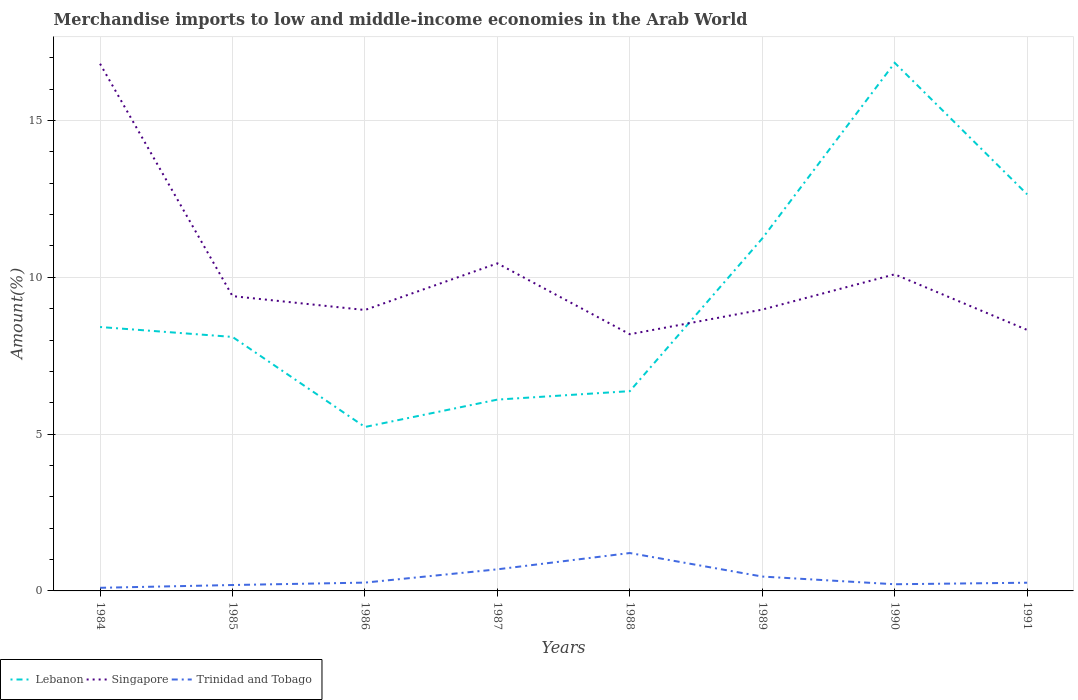Is the number of lines equal to the number of legend labels?
Give a very brief answer. Yes. Across all years, what is the maximum percentage of amount earned from merchandise imports in Lebanon?
Keep it short and to the point. 5.23. What is the total percentage of amount earned from merchandise imports in Trinidad and Tobago in the graph?
Offer a terse response. 0.43. What is the difference between the highest and the second highest percentage of amount earned from merchandise imports in Trinidad and Tobago?
Offer a very short reply. 1.11. Is the percentage of amount earned from merchandise imports in Singapore strictly greater than the percentage of amount earned from merchandise imports in Lebanon over the years?
Offer a very short reply. No. How many lines are there?
Give a very brief answer. 3. How many years are there in the graph?
Provide a short and direct response. 8. Are the values on the major ticks of Y-axis written in scientific E-notation?
Your response must be concise. No. Does the graph contain any zero values?
Ensure brevity in your answer.  No. How many legend labels are there?
Make the answer very short. 3. What is the title of the graph?
Offer a terse response. Merchandise imports to low and middle-income economies in the Arab World. Does "Latin America(developing only)" appear as one of the legend labels in the graph?
Keep it short and to the point. No. What is the label or title of the X-axis?
Provide a succinct answer. Years. What is the label or title of the Y-axis?
Offer a terse response. Amount(%). What is the Amount(%) in Lebanon in 1984?
Give a very brief answer. 8.42. What is the Amount(%) of Singapore in 1984?
Make the answer very short. 16.81. What is the Amount(%) of Trinidad and Tobago in 1984?
Keep it short and to the point. 0.1. What is the Amount(%) of Lebanon in 1985?
Your answer should be compact. 8.1. What is the Amount(%) of Singapore in 1985?
Offer a terse response. 9.4. What is the Amount(%) of Trinidad and Tobago in 1985?
Offer a terse response. 0.19. What is the Amount(%) of Lebanon in 1986?
Ensure brevity in your answer.  5.23. What is the Amount(%) of Singapore in 1986?
Your answer should be compact. 8.96. What is the Amount(%) of Trinidad and Tobago in 1986?
Your answer should be very brief. 0.26. What is the Amount(%) of Lebanon in 1987?
Provide a short and direct response. 6.1. What is the Amount(%) of Singapore in 1987?
Give a very brief answer. 10.45. What is the Amount(%) of Trinidad and Tobago in 1987?
Offer a terse response. 0.69. What is the Amount(%) of Lebanon in 1988?
Offer a very short reply. 6.37. What is the Amount(%) in Singapore in 1988?
Your answer should be very brief. 8.19. What is the Amount(%) in Trinidad and Tobago in 1988?
Your answer should be compact. 1.21. What is the Amount(%) in Lebanon in 1989?
Your answer should be very brief. 11.24. What is the Amount(%) in Singapore in 1989?
Provide a succinct answer. 8.97. What is the Amount(%) of Trinidad and Tobago in 1989?
Provide a succinct answer. 0.46. What is the Amount(%) of Lebanon in 1990?
Provide a short and direct response. 16.84. What is the Amount(%) in Singapore in 1990?
Your response must be concise. 10.1. What is the Amount(%) of Trinidad and Tobago in 1990?
Your answer should be compact. 0.21. What is the Amount(%) in Lebanon in 1991?
Your response must be concise. 12.65. What is the Amount(%) of Singapore in 1991?
Your answer should be compact. 8.32. What is the Amount(%) in Trinidad and Tobago in 1991?
Give a very brief answer. 0.26. Across all years, what is the maximum Amount(%) of Lebanon?
Your response must be concise. 16.84. Across all years, what is the maximum Amount(%) of Singapore?
Provide a short and direct response. 16.81. Across all years, what is the maximum Amount(%) in Trinidad and Tobago?
Your answer should be very brief. 1.21. Across all years, what is the minimum Amount(%) in Lebanon?
Keep it short and to the point. 5.23. Across all years, what is the minimum Amount(%) of Singapore?
Keep it short and to the point. 8.19. Across all years, what is the minimum Amount(%) in Trinidad and Tobago?
Provide a succinct answer. 0.1. What is the total Amount(%) in Lebanon in the graph?
Offer a very short reply. 74.94. What is the total Amount(%) in Singapore in the graph?
Ensure brevity in your answer.  81.19. What is the total Amount(%) in Trinidad and Tobago in the graph?
Your answer should be compact. 3.38. What is the difference between the Amount(%) in Lebanon in 1984 and that in 1985?
Make the answer very short. 0.32. What is the difference between the Amount(%) of Singapore in 1984 and that in 1985?
Your answer should be compact. 7.41. What is the difference between the Amount(%) in Trinidad and Tobago in 1984 and that in 1985?
Offer a terse response. -0.09. What is the difference between the Amount(%) in Lebanon in 1984 and that in 1986?
Offer a terse response. 3.19. What is the difference between the Amount(%) of Singapore in 1984 and that in 1986?
Provide a succinct answer. 7.85. What is the difference between the Amount(%) of Trinidad and Tobago in 1984 and that in 1986?
Your answer should be compact. -0.17. What is the difference between the Amount(%) of Lebanon in 1984 and that in 1987?
Your response must be concise. 2.31. What is the difference between the Amount(%) in Singapore in 1984 and that in 1987?
Provide a succinct answer. 6.36. What is the difference between the Amount(%) in Trinidad and Tobago in 1984 and that in 1987?
Make the answer very short. -0.59. What is the difference between the Amount(%) of Lebanon in 1984 and that in 1988?
Ensure brevity in your answer.  2.04. What is the difference between the Amount(%) of Singapore in 1984 and that in 1988?
Your answer should be compact. 8.62. What is the difference between the Amount(%) of Trinidad and Tobago in 1984 and that in 1988?
Make the answer very short. -1.11. What is the difference between the Amount(%) of Lebanon in 1984 and that in 1989?
Provide a succinct answer. -2.82. What is the difference between the Amount(%) of Singapore in 1984 and that in 1989?
Provide a succinct answer. 7.84. What is the difference between the Amount(%) of Trinidad and Tobago in 1984 and that in 1989?
Ensure brevity in your answer.  -0.36. What is the difference between the Amount(%) of Lebanon in 1984 and that in 1990?
Offer a terse response. -8.42. What is the difference between the Amount(%) in Singapore in 1984 and that in 1990?
Provide a short and direct response. 6.71. What is the difference between the Amount(%) in Trinidad and Tobago in 1984 and that in 1990?
Provide a short and direct response. -0.11. What is the difference between the Amount(%) in Lebanon in 1984 and that in 1991?
Keep it short and to the point. -4.23. What is the difference between the Amount(%) in Singapore in 1984 and that in 1991?
Offer a very short reply. 8.49. What is the difference between the Amount(%) in Trinidad and Tobago in 1984 and that in 1991?
Keep it short and to the point. -0.16. What is the difference between the Amount(%) of Lebanon in 1985 and that in 1986?
Provide a succinct answer. 2.87. What is the difference between the Amount(%) in Singapore in 1985 and that in 1986?
Your answer should be compact. 0.44. What is the difference between the Amount(%) in Trinidad and Tobago in 1985 and that in 1986?
Provide a succinct answer. -0.08. What is the difference between the Amount(%) in Lebanon in 1985 and that in 1987?
Your response must be concise. 2. What is the difference between the Amount(%) in Singapore in 1985 and that in 1987?
Offer a very short reply. -1.05. What is the difference between the Amount(%) of Trinidad and Tobago in 1985 and that in 1987?
Keep it short and to the point. -0.5. What is the difference between the Amount(%) in Lebanon in 1985 and that in 1988?
Your response must be concise. 1.73. What is the difference between the Amount(%) in Singapore in 1985 and that in 1988?
Your answer should be compact. 1.21. What is the difference between the Amount(%) of Trinidad and Tobago in 1985 and that in 1988?
Offer a very short reply. -1.02. What is the difference between the Amount(%) of Lebanon in 1985 and that in 1989?
Give a very brief answer. -3.14. What is the difference between the Amount(%) of Singapore in 1985 and that in 1989?
Offer a terse response. 0.43. What is the difference between the Amount(%) in Trinidad and Tobago in 1985 and that in 1989?
Your answer should be very brief. -0.27. What is the difference between the Amount(%) in Lebanon in 1985 and that in 1990?
Your response must be concise. -8.74. What is the difference between the Amount(%) of Singapore in 1985 and that in 1990?
Your response must be concise. -0.7. What is the difference between the Amount(%) of Trinidad and Tobago in 1985 and that in 1990?
Offer a very short reply. -0.02. What is the difference between the Amount(%) in Lebanon in 1985 and that in 1991?
Your response must be concise. -4.55. What is the difference between the Amount(%) of Singapore in 1985 and that in 1991?
Your response must be concise. 1.08. What is the difference between the Amount(%) of Trinidad and Tobago in 1985 and that in 1991?
Offer a terse response. -0.07. What is the difference between the Amount(%) in Lebanon in 1986 and that in 1987?
Your response must be concise. -0.87. What is the difference between the Amount(%) of Singapore in 1986 and that in 1987?
Provide a succinct answer. -1.49. What is the difference between the Amount(%) of Trinidad and Tobago in 1986 and that in 1987?
Give a very brief answer. -0.42. What is the difference between the Amount(%) in Lebanon in 1986 and that in 1988?
Offer a terse response. -1.14. What is the difference between the Amount(%) of Singapore in 1986 and that in 1988?
Provide a short and direct response. 0.77. What is the difference between the Amount(%) of Trinidad and Tobago in 1986 and that in 1988?
Your answer should be very brief. -0.94. What is the difference between the Amount(%) of Lebanon in 1986 and that in 1989?
Make the answer very short. -6.01. What is the difference between the Amount(%) in Singapore in 1986 and that in 1989?
Give a very brief answer. -0.01. What is the difference between the Amount(%) in Trinidad and Tobago in 1986 and that in 1989?
Your answer should be very brief. -0.19. What is the difference between the Amount(%) of Lebanon in 1986 and that in 1990?
Make the answer very short. -11.61. What is the difference between the Amount(%) of Singapore in 1986 and that in 1990?
Give a very brief answer. -1.14. What is the difference between the Amount(%) of Trinidad and Tobago in 1986 and that in 1990?
Make the answer very short. 0.05. What is the difference between the Amount(%) of Lebanon in 1986 and that in 1991?
Your answer should be compact. -7.42. What is the difference between the Amount(%) of Singapore in 1986 and that in 1991?
Provide a succinct answer. 0.64. What is the difference between the Amount(%) of Trinidad and Tobago in 1986 and that in 1991?
Make the answer very short. 0. What is the difference between the Amount(%) in Lebanon in 1987 and that in 1988?
Your answer should be compact. -0.27. What is the difference between the Amount(%) in Singapore in 1987 and that in 1988?
Your response must be concise. 2.26. What is the difference between the Amount(%) in Trinidad and Tobago in 1987 and that in 1988?
Your answer should be compact. -0.52. What is the difference between the Amount(%) of Lebanon in 1987 and that in 1989?
Your answer should be very brief. -5.14. What is the difference between the Amount(%) in Singapore in 1987 and that in 1989?
Your answer should be compact. 1.47. What is the difference between the Amount(%) of Trinidad and Tobago in 1987 and that in 1989?
Ensure brevity in your answer.  0.23. What is the difference between the Amount(%) in Lebanon in 1987 and that in 1990?
Make the answer very short. -10.74. What is the difference between the Amount(%) in Singapore in 1987 and that in 1990?
Ensure brevity in your answer.  0.35. What is the difference between the Amount(%) in Trinidad and Tobago in 1987 and that in 1990?
Provide a short and direct response. 0.48. What is the difference between the Amount(%) of Lebanon in 1987 and that in 1991?
Provide a short and direct response. -6.55. What is the difference between the Amount(%) of Singapore in 1987 and that in 1991?
Provide a succinct answer. 2.12. What is the difference between the Amount(%) of Trinidad and Tobago in 1987 and that in 1991?
Provide a short and direct response. 0.43. What is the difference between the Amount(%) of Lebanon in 1988 and that in 1989?
Your answer should be very brief. -4.87. What is the difference between the Amount(%) in Singapore in 1988 and that in 1989?
Make the answer very short. -0.79. What is the difference between the Amount(%) in Trinidad and Tobago in 1988 and that in 1989?
Your answer should be very brief. 0.75. What is the difference between the Amount(%) of Lebanon in 1988 and that in 1990?
Offer a terse response. -10.47. What is the difference between the Amount(%) in Singapore in 1988 and that in 1990?
Keep it short and to the point. -1.91. What is the difference between the Amount(%) in Lebanon in 1988 and that in 1991?
Your answer should be very brief. -6.28. What is the difference between the Amount(%) in Singapore in 1988 and that in 1991?
Keep it short and to the point. -0.14. What is the difference between the Amount(%) in Trinidad and Tobago in 1988 and that in 1991?
Offer a terse response. 0.95. What is the difference between the Amount(%) in Lebanon in 1989 and that in 1990?
Ensure brevity in your answer.  -5.6. What is the difference between the Amount(%) in Singapore in 1989 and that in 1990?
Ensure brevity in your answer.  -1.12. What is the difference between the Amount(%) of Trinidad and Tobago in 1989 and that in 1990?
Keep it short and to the point. 0.25. What is the difference between the Amount(%) in Lebanon in 1989 and that in 1991?
Give a very brief answer. -1.41. What is the difference between the Amount(%) in Singapore in 1989 and that in 1991?
Offer a very short reply. 0.65. What is the difference between the Amount(%) in Trinidad and Tobago in 1989 and that in 1991?
Offer a very short reply. 0.2. What is the difference between the Amount(%) of Lebanon in 1990 and that in 1991?
Provide a succinct answer. 4.19. What is the difference between the Amount(%) in Singapore in 1990 and that in 1991?
Your answer should be very brief. 1.77. What is the difference between the Amount(%) in Trinidad and Tobago in 1990 and that in 1991?
Offer a very short reply. -0.05. What is the difference between the Amount(%) in Lebanon in 1984 and the Amount(%) in Singapore in 1985?
Offer a terse response. -0.98. What is the difference between the Amount(%) in Lebanon in 1984 and the Amount(%) in Trinidad and Tobago in 1985?
Make the answer very short. 8.23. What is the difference between the Amount(%) of Singapore in 1984 and the Amount(%) of Trinidad and Tobago in 1985?
Provide a succinct answer. 16.62. What is the difference between the Amount(%) of Lebanon in 1984 and the Amount(%) of Singapore in 1986?
Provide a short and direct response. -0.54. What is the difference between the Amount(%) of Lebanon in 1984 and the Amount(%) of Trinidad and Tobago in 1986?
Ensure brevity in your answer.  8.15. What is the difference between the Amount(%) of Singapore in 1984 and the Amount(%) of Trinidad and Tobago in 1986?
Your answer should be compact. 16.54. What is the difference between the Amount(%) of Lebanon in 1984 and the Amount(%) of Singapore in 1987?
Offer a terse response. -2.03. What is the difference between the Amount(%) of Lebanon in 1984 and the Amount(%) of Trinidad and Tobago in 1987?
Your answer should be compact. 7.73. What is the difference between the Amount(%) in Singapore in 1984 and the Amount(%) in Trinidad and Tobago in 1987?
Offer a terse response. 16.12. What is the difference between the Amount(%) in Lebanon in 1984 and the Amount(%) in Singapore in 1988?
Provide a short and direct response. 0.23. What is the difference between the Amount(%) of Lebanon in 1984 and the Amount(%) of Trinidad and Tobago in 1988?
Make the answer very short. 7.21. What is the difference between the Amount(%) in Singapore in 1984 and the Amount(%) in Trinidad and Tobago in 1988?
Provide a short and direct response. 15.6. What is the difference between the Amount(%) of Lebanon in 1984 and the Amount(%) of Singapore in 1989?
Your answer should be compact. -0.56. What is the difference between the Amount(%) of Lebanon in 1984 and the Amount(%) of Trinidad and Tobago in 1989?
Give a very brief answer. 7.96. What is the difference between the Amount(%) in Singapore in 1984 and the Amount(%) in Trinidad and Tobago in 1989?
Provide a short and direct response. 16.35. What is the difference between the Amount(%) in Lebanon in 1984 and the Amount(%) in Singapore in 1990?
Provide a short and direct response. -1.68. What is the difference between the Amount(%) of Lebanon in 1984 and the Amount(%) of Trinidad and Tobago in 1990?
Keep it short and to the point. 8.2. What is the difference between the Amount(%) of Singapore in 1984 and the Amount(%) of Trinidad and Tobago in 1990?
Your response must be concise. 16.6. What is the difference between the Amount(%) of Lebanon in 1984 and the Amount(%) of Singapore in 1991?
Offer a very short reply. 0.09. What is the difference between the Amount(%) in Lebanon in 1984 and the Amount(%) in Trinidad and Tobago in 1991?
Your response must be concise. 8.15. What is the difference between the Amount(%) in Singapore in 1984 and the Amount(%) in Trinidad and Tobago in 1991?
Your answer should be very brief. 16.55. What is the difference between the Amount(%) in Lebanon in 1985 and the Amount(%) in Singapore in 1986?
Give a very brief answer. -0.86. What is the difference between the Amount(%) in Lebanon in 1985 and the Amount(%) in Trinidad and Tobago in 1986?
Offer a very short reply. 7.83. What is the difference between the Amount(%) in Singapore in 1985 and the Amount(%) in Trinidad and Tobago in 1986?
Your answer should be very brief. 9.13. What is the difference between the Amount(%) of Lebanon in 1985 and the Amount(%) of Singapore in 1987?
Offer a terse response. -2.35. What is the difference between the Amount(%) in Lebanon in 1985 and the Amount(%) in Trinidad and Tobago in 1987?
Offer a terse response. 7.41. What is the difference between the Amount(%) in Singapore in 1985 and the Amount(%) in Trinidad and Tobago in 1987?
Your answer should be compact. 8.71. What is the difference between the Amount(%) of Lebanon in 1985 and the Amount(%) of Singapore in 1988?
Give a very brief answer. -0.09. What is the difference between the Amount(%) in Lebanon in 1985 and the Amount(%) in Trinidad and Tobago in 1988?
Your answer should be compact. 6.89. What is the difference between the Amount(%) of Singapore in 1985 and the Amount(%) of Trinidad and Tobago in 1988?
Give a very brief answer. 8.19. What is the difference between the Amount(%) in Lebanon in 1985 and the Amount(%) in Singapore in 1989?
Keep it short and to the point. -0.87. What is the difference between the Amount(%) of Lebanon in 1985 and the Amount(%) of Trinidad and Tobago in 1989?
Offer a very short reply. 7.64. What is the difference between the Amount(%) in Singapore in 1985 and the Amount(%) in Trinidad and Tobago in 1989?
Give a very brief answer. 8.94. What is the difference between the Amount(%) in Lebanon in 1985 and the Amount(%) in Singapore in 1990?
Your response must be concise. -2. What is the difference between the Amount(%) of Lebanon in 1985 and the Amount(%) of Trinidad and Tobago in 1990?
Your answer should be compact. 7.89. What is the difference between the Amount(%) of Singapore in 1985 and the Amount(%) of Trinidad and Tobago in 1990?
Make the answer very short. 9.19. What is the difference between the Amount(%) of Lebanon in 1985 and the Amount(%) of Singapore in 1991?
Your answer should be very brief. -0.22. What is the difference between the Amount(%) in Lebanon in 1985 and the Amount(%) in Trinidad and Tobago in 1991?
Keep it short and to the point. 7.84. What is the difference between the Amount(%) in Singapore in 1985 and the Amount(%) in Trinidad and Tobago in 1991?
Your answer should be compact. 9.14. What is the difference between the Amount(%) in Lebanon in 1986 and the Amount(%) in Singapore in 1987?
Ensure brevity in your answer.  -5.22. What is the difference between the Amount(%) of Lebanon in 1986 and the Amount(%) of Trinidad and Tobago in 1987?
Your answer should be compact. 4.54. What is the difference between the Amount(%) of Singapore in 1986 and the Amount(%) of Trinidad and Tobago in 1987?
Offer a very short reply. 8.27. What is the difference between the Amount(%) of Lebanon in 1986 and the Amount(%) of Singapore in 1988?
Offer a terse response. -2.96. What is the difference between the Amount(%) in Lebanon in 1986 and the Amount(%) in Trinidad and Tobago in 1988?
Ensure brevity in your answer.  4.02. What is the difference between the Amount(%) of Singapore in 1986 and the Amount(%) of Trinidad and Tobago in 1988?
Ensure brevity in your answer.  7.75. What is the difference between the Amount(%) in Lebanon in 1986 and the Amount(%) in Singapore in 1989?
Offer a terse response. -3.74. What is the difference between the Amount(%) of Lebanon in 1986 and the Amount(%) of Trinidad and Tobago in 1989?
Your answer should be very brief. 4.77. What is the difference between the Amount(%) in Singapore in 1986 and the Amount(%) in Trinidad and Tobago in 1989?
Provide a short and direct response. 8.5. What is the difference between the Amount(%) in Lebanon in 1986 and the Amount(%) in Singapore in 1990?
Your answer should be compact. -4.87. What is the difference between the Amount(%) in Lebanon in 1986 and the Amount(%) in Trinidad and Tobago in 1990?
Your answer should be very brief. 5.02. What is the difference between the Amount(%) of Singapore in 1986 and the Amount(%) of Trinidad and Tobago in 1990?
Keep it short and to the point. 8.75. What is the difference between the Amount(%) of Lebanon in 1986 and the Amount(%) of Singapore in 1991?
Provide a succinct answer. -3.1. What is the difference between the Amount(%) in Lebanon in 1986 and the Amount(%) in Trinidad and Tobago in 1991?
Make the answer very short. 4.97. What is the difference between the Amount(%) of Singapore in 1986 and the Amount(%) of Trinidad and Tobago in 1991?
Your answer should be compact. 8.7. What is the difference between the Amount(%) of Lebanon in 1987 and the Amount(%) of Singapore in 1988?
Provide a succinct answer. -2.08. What is the difference between the Amount(%) in Lebanon in 1987 and the Amount(%) in Trinidad and Tobago in 1988?
Keep it short and to the point. 4.89. What is the difference between the Amount(%) in Singapore in 1987 and the Amount(%) in Trinidad and Tobago in 1988?
Ensure brevity in your answer.  9.24. What is the difference between the Amount(%) of Lebanon in 1987 and the Amount(%) of Singapore in 1989?
Provide a succinct answer. -2.87. What is the difference between the Amount(%) of Lebanon in 1987 and the Amount(%) of Trinidad and Tobago in 1989?
Provide a succinct answer. 5.64. What is the difference between the Amount(%) in Singapore in 1987 and the Amount(%) in Trinidad and Tobago in 1989?
Give a very brief answer. 9.99. What is the difference between the Amount(%) in Lebanon in 1987 and the Amount(%) in Singapore in 1990?
Offer a very short reply. -4. What is the difference between the Amount(%) in Lebanon in 1987 and the Amount(%) in Trinidad and Tobago in 1990?
Provide a short and direct response. 5.89. What is the difference between the Amount(%) of Singapore in 1987 and the Amount(%) of Trinidad and Tobago in 1990?
Provide a succinct answer. 10.23. What is the difference between the Amount(%) in Lebanon in 1987 and the Amount(%) in Singapore in 1991?
Ensure brevity in your answer.  -2.22. What is the difference between the Amount(%) of Lebanon in 1987 and the Amount(%) of Trinidad and Tobago in 1991?
Offer a terse response. 5.84. What is the difference between the Amount(%) in Singapore in 1987 and the Amount(%) in Trinidad and Tobago in 1991?
Provide a succinct answer. 10.18. What is the difference between the Amount(%) in Lebanon in 1988 and the Amount(%) in Singapore in 1989?
Make the answer very short. -2.6. What is the difference between the Amount(%) in Lebanon in 1988 and the Amount(%) in Trinidad and Tobago in 1989?
Ensure brevity in your answer.  5.91. What is the difference between the Amount(%) of Singapore in 1988 and the Amount(%) of Trinidad and Tobago in 1989?
Keep it short and to the point. 7.73. What is the difference between the Amount(%) in Lebanon in 1988 and the Amount(%) in Singapore in 1990?
Provide a succinct answer. -3.73. What is the difference between the Amount(%) in Lebanon in 1988 and the Amount(%) in Trinidad and Tobago in 1990?
Provide a succinct answer. 6.16. What is the difference between the Amount(%) in Singapore in 1988 and the Amount(%) in Trinidad and Tobago in 1990?
Your response must be concise. 7.97. What is the difference between the Amount(%) in Lebanon in 1988 and the Amount(%) in Singapore in 1991?
Keep it short and to the point. -1.95. What is the difference between the Amount(%) in Lebanon in 1988 and the Amount(%) in Trinidad and Tobago in 1991?
Your answer should be compact. 6.11. What is the difference between the Amount(%) in Singapore in 1988 and the Amount(%) in Trinidad and Tobago in 1991?
Ensure brevity in your answer.  7.92. What is the difference between the Amount(%) of Lebanon in 1989 and the Amount(%) of Trinidad and Tobago in 1990?
Keep it short and to the point. 11.03. What is the difference between the Amount(%) of Singapore in 1989 and the Amount(%) of Trinidad and Tobago in 1990?
Provide a short and direct response. 8.76. What is the difference between the Amount(%) in Lebanon in 1989 and the Amount(%) in Singapore in 1991?
Your answer should be very brief. 2.92. What is the difference between the Amount(%) in Lebanon in 1989 and the Amount(%) in Trinidad and Tobago in 1991?
Give a very brief answer. 10.98. What is the difference between the Amount(%) of Singapore in 1989 and the Amount(%) of Trinidad and Tobago in 1991?
Your answer should be very brief. 8.71. What is the difference between the Amount(%) of Lebanon in 1990 and the Amount(%) of Singapore in 1991?
Your answer should be compact. 8.52. What is the difference between the Amount(%) in Lebanon in 1990 and the Amount(%) in Trinidad and Tobago in 1991?
Your answer should be compact. 16.58. What is the difference between the Amount(%) in Singapore in 1990 and the Amount(%) in Trinidad and Tobago in 1991?
Offer a very short reply. 9.83. What is the average Amount(%) in Lebanon per year?
Provide a short and direct response. 9.37. What is the average Amount(%) of Singapore per year?
Your response must be concise. 10.15. What is the average Amount(%) of Trinidad and Tobago per year?
Offer a terse response. 0.42. In the year 1984, what is the difference between the Amount(%) of Lebanon and Amount(%) of Singapore?
Offer a terse response. -8.39. In the year 1984, what is the difference between the Amount(%) in Lebanon and Amount(%) in Trinidad and Tobago?
Offer a very short reply. 8.32. In the year 1984, what is the difference between the Amount(%) in Singapore and Amount(%) in Trinidad and Tobago?
Make the answer very short. 16.71. In the year 1985, what is the difference between the Amount(%) in Lebanon and Amount(%) in Singapore?
Give a very brief answer. -1.3. In the year 1985, what is the difference between the Amount(%) of Lebanon and Amount(%) of Trinidad and Tobago?
Provide a succinct answer. 7.91. In the year 1985, what is the difference between the Amount(%) of Singapore and Amount(%) of Trinidad and Tobago?
Your response must be concise. 9.21. In the year 1986, what is the difference between the Amount(%) in Lebanon and Amount(%) in Singapore?
Ensure brevity in your answer.  -3.73. In the year 1986, what is the difference between the Amount(%) in Lebanon and Amount(%) in Trinidad and Tobago?
Offer a very short reply. 4.96. In the year 1986, what is the difference between the Amount(%) of Singapore and Amount(%) of Trinidad and Tobago?
Offer a terse response. 8.69. In the year 1987, what is the difference between the Amount(%) of Lebanon and Amount(%) of Singapore?
Give a very brief answer. -4.34. In the year 1987, what is the difference between the Amount(%) in Lebanon and Amount(%) in Trinidad and Tobago?
Give a very brief answer. 5.41. In the year 1987, what is the difference between the Amount(%) of Singapore and Amount(%) of Trinidad and Tobago?
Give a very brief answer. 9.76. In the year 1988, what is the difference between the Amount(%) in Lebanon and Amount(%) in Singapore?
Ensure brevity in your answer.  -1.81. In the year 1988, what is the difference between the Amount(%) of Lebanon and Amount(%) of Trinidad and Tobago?
Offer a terse response. 5.16. In the year 1988, what is the difference between the Amount(%) of Singapore and Amount(%) of Trinidad and Tobago?
Your answer should be compact. 6.98. In the year 1989, what is the difference between the Amount(%) in Lebanon and Amount(%) in Singapore?
Your response must be concise. 2.27. In the year 1989, what is the difference between the Amount(%) of Lebanon and Amount(%) of Trinidad and Tobago?
Offer a very short reply. 10.78. In the year 1989, what is the difference between the Amount(%) in Singapore and Amount(%) in Trinidad and Tobago?
Make the answer very short. 8.51. In the year 1990, what is the difference between the Amount(%) of Lebanon and Amount(%) of Singapore?
Provide a succinct answer. 6.74. In the year 1990, what is the difference between the Amount(%) of Lebanon and Amount(%) of Trinidad and Tobago?
Give a very brief answer. 16.63. In the year 1990, what is the difference between the Amount(%) in Singapore and Amount(%) in Trinidad and Tobago?
Offer a very short reply. 9.88. In the year 1991, what is the difference between the Amount(%) in Lebanon and Amount(%) in Singapore?
Your answer should be very brief. 4.32. In the year 1991, what is the difference between the Amount(%) in Lebanon and Amount(%) in Trinidad and Tobago?
Give a very brief answer. 12.38. In the year 1991, what is the difference between the Amount(%) of Singapore and Amount(%) of Trinidad and Tobago?
Make the answer very short. 8.06. What is the ratio of the Amount(%) in Lebanon in 1984 to that in 1985?
Keep it short and to the point. 1.04. What is the ratio of the Amount(%) in Singapore in 1984 to that in 1985?
Ensure brevity in your answer.  1.79. What is the ratio of the Amount(%) of Trinidad and Tobago in 1984 to that in 1985?
Offer a very short reply. 0.53. What is the ratio of the Amount(%) in Lebanon in 1984 to that in 1986?
Your response must be concise. 1.61. What is the ratio of the Amount(%) in Singapore in 1984 to that in 1986?
Provide a short and direct response. 1.88. What is the ratio of the Amount(%) in Trinidad and Tobago in 1984 to that in 1986?
Give a very brief answer. 0.38. What is the ratio of the Amount(%) of Lebanon in 1984 to that in 1987?
Make the answer very short. 1.38. What is the ratio of the Amount(%) in Singapore in 1984 to that in 1987?
Provide a short and direct response. 1.61. What is the ratio of the Amount(%) of Trinidad and Tobago in 1984 to that in 1987?
Provide a short and direct response. 0.14. What is the ratio of the Amount(%) in Lebanon in 1984 to that in 1988?
Ensure brevity in your answer.  1.32. What is the ratio of the Amount(%) in Singapore in 1984 to that in 1988?
Offer a very short reply. 2.05. What is the ratio of the Amount(%) in Trinidad and Tobago in 1984 to that in 1988?
Keep it short and to the point. 0.08. What is the ratio of the Amount(%) of Lebanon in 1984 to that in 1989?
Offer a very short reply. 0.75. What is the ratio of the Amount(%) of Singapore in 1984 to that in 1989?
Your answer should be very brief. 1.87. What is the ratio of the Amount(%) of Trinidad and Tobago in 1984 to that in 1989?
Provide a short and direct response. 0.22. What is the ratio of the Amount(%) of Lebanon in 1984 to that in 1990?
Make the answer very short. 0.5. What is the ratio of the Amount(%) of Singapore in 1984 to that in 1990?
Make the answer very short. 1.67. What is the ratio of the Amount(%) in Trinidad and Tobago in 1984 to that in 1990?
Make the answer very short. 0.47. What is the ratio of the Amount(%) in Lebanon in 1984 to that in 1991?
Your answer should be very brief. 0.67. What is the ratio of the Amount(%) in Singapore in 1984 to that in 1991?
Provide a succinct answer. 2.02. What is the ratio of the Amount(%) of Trinidad and Tobago in 1984 to that in 1991?
Your answer should be very brief. 0.38. What is the ratio of the Amount(%) in Lebanon in 1985 to that in 1986?
Make the answer very short. 1.55. What is the ratio of the Amount(%) in Singapore in 1985 to that in 1986?
Give a very brief answer. 1.05. What is the ratio of the Amount(%) of Trinidad and Tobago in 1985 to that in 1986?
Your answer should be very brief. 0.71. What is the ratio of the Amount(%) in Lebanon in 1985 to that in 1987?
Provide a short and direct response. 1.33. What is the ratio of the Amount(%) in Singapore in 1985 to that in 1987?
Provide a succinct answer. 0.9. What is the ratio of the Amount(%) in Trinidad and Tobago in 1985 to that in 1987?
Your response must be concise. 0.27. What is the ratio of the Amount(%) of Lebanon in 1985 to that in 1988?
Ensure brevity in your answer.  1.27. What is the ratio of the Amount(%) of Singapore in 1985 to that in 1988?
Your answer should be very brief. 1.15. What is the ratio of the Amount(%) of Trinidad and Tobago in 1985 to that in 1988?
Your answer should be very brief. 0.16. What is the ratio of the Amount(%) in Lebanon in 1985 to that in 1989?
Keep it short and to the point. 0.72. What is the ratio of the Amount(%) in Singapore in 1985 to that in 1989?
Offer a very short reply. 1.05. What is the ratio of the Amount(%) of Trinidad and Tobago in 1985 to that in 1989?
Keep it short and to the point. 0.41. What is the ratio of the Amount(%) in Lebanon in 1985 to that in 1990?
Your answer should be very brief. 0.48. What is the ratio of the Amount(%) of Trinidad and Tobago in 1985 to that in 1990?
Your answer should be compact. 0.89. What is the ratio of the Amount(%) in Lebanon in 1985 to that in 1991?
Provide a succinct answer. 0.64. What is the ratio of the Amount(%) in Singapore in 1985 to that in 1991?
Offer a very short reply. 1.13. What is the ratio of the Amount(%) in Trinidad and Tobago in 1985 to that in 1991?
Your answer should be compact. 0.72. What is the ratio of the Amount(%) of Lebanon in 1986 to that in 1987?
Your response must be concise. 0.86. What is the ratio of the Amount(%) of Singapore in 1986 to that in 1987?
Give a very brief answer. 0.86. What is the ratio of the Amount(%) of Trinidad and Tobago in 1986 to that in 1987?
Ensure brevity in your answer.  0.38. What is the ratio of the Amount(%) in Lebanon in 1986 to that in 1988?
Your answer should be very brief. 0.82. What is the ratio of the Amount(%) of Singapore in 1986 to that in 1988?
Provide a succinct answer. 1.09. What is the ratio of the Amount(%) of Trinidad and Tobago in 1986 to that in 1988?
Provide a succinct answer. 0.22. What is the ratio of the Amount(%) of Lebanon in 1986 to that in 1989?
Offer a very short reply. 0.47. What is the ratio of the Amount(%) in Singapore in 1986 to that in 1989?
Give a very brief answer. 1. What is the ratio of the Amount(%) in Trinidad and Tobago in 1986 to that in 1989?
Ensure brevity in your answer.  0.58. What is the ratio of the Amount(%) of Lebanon in 1986 to that in 1990?
Offer a very short reply. 0.31. What is the ratio of the Amount(%) of Singapore in 1986 to that in 1990?
Give a very brief answer. 0.89. What is the ratio of the Amount(%) in Trinidad and Tobago in 1986 to that in 1990?
Offer a terse response. 1.25. What is the ratio of the Amount(%) in Lebanon in 1986 to that in 1991?
Your answer should be compact. 0.41. What is the ratio of the Amount(%) in Singapore in 1986 to that in 1991?
Your response must be concise. 1.08. What is the ratio of the Amount(%) in Trinidad and Tobago in 1986 to that in 1991?
Provide a short and direct response. 1.01. What is the ratio of the Amount(%) of Lebanon in 1987 to that in 1988?
Your response must be concise. 0.96. What is the ratio of the Amount(%) of Singapore in 1987 to that in 1988?
Keep it short and to the point. 1.28. What is the ratio of the Amount(%) of Trinidad and Tobago in 1987 to that in 1988?
Provide a succinct answer. 0.57. What is the ratio of the Amount(%) of Lebanon in 1987 to that in 1989?
Keep it short and to the point. 0.54. What is the ratio of the Amount(%) in Singapore in 1987 to that in 1989?
Your answer should be compact. 1.16. What is the ratio of the Amount(%) in Trinidad and Tobago in 1987 to that in 1989?
Ensure brevity in your answer.  1.5. What is the ratio of the Amount(%) of Lebanon in 1987 to that in 1990?
Offer a very short reply. 0.36. What is the ratio of the Amount(%) in Singapore in 1987 to that in 1990?
Provide a succinct answer. 1.03. What is the ratio of the Amount(%) of Trinidad and Tobago in 1987 to that in 1990?
Provide a short and direct response. 3.24. What is the ratio of the Amount(%) of Lebanon in 1987 to that in 1991?
Your response must be concise. 0.48. What is the ratio of the Amount(%) in Singapore in 1987 to that in 1991?
Your response must be concise. 1.25. What is the ratio of the Amount(%) of Trinidad and Tobago in 1987 to that in 1991?
Offer a terse response. 2.63. What is the ratio of the Amount(%) of Lebanon in 1988 to that in 1989?
Keep it short and to the point. 0.57. What is the ratio of the Amount(%) of Singapore in 1988 to that in 1989?
Your response must be concise. 0.91. What is the ratio of the Amount(%) in Trinidad and Tobago in 1988 to that in 1989?
Give a very brief answer. 2.64. What is the ratio of the Amount(%) in Lebanon in 1988 to that in 1990?
Your answer should be compact. 0.38. What is the ratio of the Amount(%) in Singapore in 1988 to that in 1990?
Offer a very short reply. 0.81. What is the ratio of the Amount(%) of Trinidad and Tobago in 1988 to that in 1990?
Ensure brevity in your answer.  5.68. What is the ratio of the Amount(%) of Lebanon in 1988 to that in 1991?
Your answer should be compact. 0.5. What is the ratio of the Amount(%) of Singapore in 1988 to that in 1991?
Keep it short and to the point. 0.98. What is the ratio of the Amount(%) in Trinidad and Tobago in 1988 to that in 1991?
Keep it short and to the point. 4.62. What is the ratio of the Amount(%) in Lebanon in 1989 to that in 1990?
Offer a very short reply. 0.67. What is the ratio of the Amount(%) of Singapore in 1989 to that in 1990?
Your response must be concise. 0.89. What is the ratio of the Amount(%) of Trinidad and Tobago in 1989 to that in 1990?
Your answer should be very brief. 2.15. What is the ratio of the Amount(%) in Lebanon in 1989 to that in 1991?
Your response must be concise. 0.89. What is the ratio of the Amount(%) of Singapore in 1989 to that in 1991?
Your answer should be compact. 1.08. What is the ratio of the Amount(%) of Trinidad and Tobago in 1989 to that in 1991?
Offer a terse response. 1.75. What is the ratio of the Amount(%) in Lebanon in 1990 to that in 1991?
Make the answer very short. 1.33. What is the ratio of the Amount(%) in Singapore in 1990 to that in 1991?
Give a very brief answer. 1.21. What is the ratio of the Amount(%) in Trinidad and Tobago in 1990 to that in 1991?
Make the answer very short. 0.81. What is the difference between the highest and the second highest Amount(%) of Lebanon?
Ensure brevity in your answer.  4.19. What is the difference between the highest and the second highest Amount(%) in Singapore?
Your response must be concise. 6.36. What is the difference between the highest and the second highest Amount(%) of Trinidad and Tobago?
Give a very brief answer. 0.52. What is the difference between the highest and the lowest Amount(%) of Lebanon?
Ensure brevity in your answer.  11.61. What is the difference between the highest and the lowest Amount(%) in Singapore?
Give a very brief answer. 8.62. What is the difference between the highest and the lowest Amount(%) in Trinidad and Tobago?
Offer a very short reply. 1.11. 